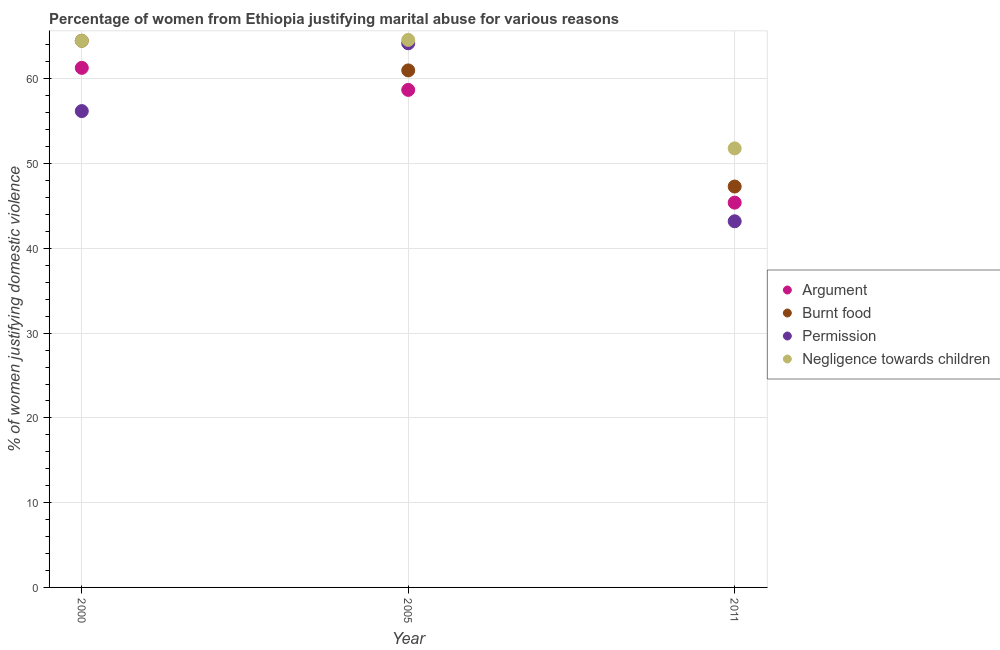How many different coloured dotlines are there?
Your answer should be compact. 4. Is the number of dotlines equal to the number of legend labels?
Ensure brevity in your answer.  Yes. What is the percentage of women justifying abuse for going without permission in 2011?
Make the answer very short. 43.2. Across all years, what is the maximum percentage of women justifying abuse in the case of an argument?
Ensure brevity in your answer.  61.3. Across all years, what is the minimum percentage of women justifying abuse for burning food?
Offer a terse response. 47.3. In which year was the percentage of women justifying abuse in the case of an argument maximum?
Give a very brief answer. 2000. In which year was the percentage of women justifying abuse for going without permission minimum?
Give a very brief answer. 2011. What is the total percentage of women justifying abuse for going without permission in the graph?
Offer a terse response. 163.6. What is the difference between the percentage of women justifying abuse for showing negligence towards children in 2000 and that in 2011?
Your answer should be very brief. 12.7. What is the difference between the percentage of women justifying abuse for showing negligence towards children in 2011 and the percentage of women justifying abuse for burning food in 2000?
Keep it short and to the point. -12.7. What is the average percentage of women justifying abuse in the case of an argument per year?
Make the answer very short. 55.13. In the year 2000, what is the difference between the percentage of women justifying abuse in the case of an argument and percentage of women justifying abuse for burning food?
Keep it short and to the point. -3.2. What is the ratio of the percentage of women justifying abuse for showing negligence towards children in 2000 to that in 2011?
Make the answer very short. 1.25. What is the difference between the highest and the second highest percentage of women justifying abuse in the case of an argument?
Your response must be concise. 2.6. What is the difference between the highest and the lowest percentage of women justifying abuse for burning food?
Make the answer very short. 17.2. In how many years, is the percentage of women justifying abuse in the case of an argument greater than the average percentage of women justifying abuse in the case of an argument taken over all years?
Make the answer very short. 2. Does the percentage of women justifying abuse for showing negligence towards children monotonically increase over the years?
Ensure brevity in your answer.  No. Is the percentage of women justifying abuse in the case of an argument strictly greater than the percentage of women justifying abuse for burning food over the years?
Your response must be concise. No. Is the percentage of women justifying abuse for showing negligence towards children strictly less than the percentage of women justifying abuse for burning food over the years?
Ensure brevity in your answer.  No. How many dotlines are there?
Keep it short and to the point. 4. How many years are there in the graph?
Keep it short and to the point. 3. Are the values on the major ticks of Y-axis written in scientific E-notation?
Provide a short and direct response. No. Does the graph contain grids?
Your answer should be very brief. Yes. How are the legend labels stacked?
Ensure brevity in your answer.  Vertical. What is the title of the graph?
Make the answer very short. Percentage of women from Ethiopia justifying marital abuse for various reasons. Does "Gender equality" appear as one of the legend labels in the graph?
Provide a succinct answer. No. What is the label or title of the X-axis?
Keep it short and to the point. Year. What is the label or title of the Y-axis?
Offer a very short reply. % of women justifying domestic violence. What is the % of women justifying domestic violence in Argument in 2000?
Your response must be concise. 61.3. What is the % of women justifying domestic violence of Burnt food in 2000?
Make the answer very short. 64.5. What is the % of women justifying domestic violence of Permission in 2000?
Your response must be concise. 56.2. What is the % of women justifying domestic violence of Negligence towards children in 2000?
Give a very brief answer. 64.5. What is the % of women justifying domestic violence in Argument in 2005?
Offer a terse response. 58.7. What is the % of women justifying domestic violence of Burnt food in 2005?
Provide a short and direct response. 61. What is the % of women justifying domestic violence in Permission in 2005?
Your answer should be compact. 64.2. What is the % of women justifying domestic violence in Negligence towards children in 2005?
Your answer should be compact. 64.6. What is the % of women justifying domestic violence of Argument in 2011?
Ensure brevity in your answer.  45.4. What is the % of women justifying domestic violence of Burnt food in 2011?
Offer a very short reply. 47.3. What is the % of women justifying domestic violence in Permission in 2011?
Offer a very short reply. 43.2. What is the % of women justifying domestic violence of Negligence towards children in 2011?
Ensure brevity in your answer.  51.8. Across all years, what is the maximum % of women justifying domestic violence in Argument?
Make the answer very short. 61.3. Across all years, what is the maximum % of women justifying domestic violence of Burnt food?
Offer a terse response. 64.5. Across all years, what is the maximum % of women justifying domestic violence of Permission?
Offer a very short reply. 64.2. Across all years, what is the maximum % of women justifying domestic violence in Negligence towards children?
Your response must be concise. 64.6. Across all years, what is the minimum % of women justifying domestic violence of Argument?
Give a very brief answer. 45.4. Across all years, what is the minimum % of women justifying domestic violence in Burnt food?
Provide a short and direct response. 47.3. Across all years, what is the minimum % of women justifying domestic violence in Permission?
Your answer should be compact. 43.2. Across all years, what is the minimum % of women justifying domestic violence of Negligence towards children?
Provide a short and direct response. 51.8. What is the total % of women justifying domestic violence of Argument in the graph?
Your response must be concise. 165.4. What is the total % of women justifying domestic violence of Burnt food in the graph?
Provide a short and direct response. 172.8. What is the total % of women justifying domestic violence of Permission in the graph?
Your response must be concise. 163.6. What is the total % of women justifying domestic violence in Negligence towards children in the graph?
Make the answer very short. 180.9. What is the difference between the % of women justifying domestic violence of Argument in 2000 and that in 2005?
Give a very brief answer. 2.6. What is the difference between the % of women justifying domestic violence of Argument in 2000 and that in 2011?
Ensure brevity in your answer.  15.9. What is the difference between the % of women justifying domestic violence of Burnt food in 2000 and that in 2011?
Give a very brief answer. 17.2. What is the difference between the % of women justifying domestic violence in Negligence towards children in 2000 and that in 2011?
Offer a terse response. 12.7. What is the difference between the % of women justifying domestic violence of Argument in 2005 and that in 2011?
Make the answer very short. 13.3. What is the difference between the % of women justifying domestic violence of Burnt food in 2005 and that in 2011?
Provide a short and direct response. 13.7. What is the difference between the % of women justifying domestic violence of Permission in 2005 and that in 2011?
Offer a very short reply. 21. What is the difference between the % of women justifying domestic violence in Argument in 2000 and the % of women justifying domestic violence in Negligence towards children in 2005?
Give a very brief answer. -3.3. What is the difference between the % of women justifying domestic violence of Burnt food in 2000 and the % of women justifying domestic violence of Permission in 2005?
Provide a short and direct response. 0.3. What is the difference between the % of women justifying domestic violence of Argument in 2000 and the % of women justifying domestic violence of Burnt food in 2011?
Your answer should be compact. 14. What is the difference between the % of women justifying domestic violence in Argument in 2000 and the % of women justifying domestic violence in Permission in 2011?
Provide a short and direct response. 18.1. What is the difference between the % of women justifying domestic violence in Burnt food in 2000 and the % of women justifying domestic violence in Permission in 2011?
Make the answer very short. 21.3. What is the difference between the % of women justifying domestic violence of Permission in 2000 and the % of women justifying domestic violence of Negligence towards children in 2011?
Your response must be concise. 4.4. What is the difference between the % of women justifying domestic violence of Argument in 2005 and the % of women justifying domestic violence of Permission in 2011?
Ensure brevity in your answer.  15.5. What is the difference between the % of women justifying domestic violence in Burnt food in 2005 and the % of women justifying domestic violence in Negligence towards children in 2011?
Provide a succinct answer. 9.2. What is the difference between the % of women justifying domestic violence in Permission in 2005 and the % of women justifying domestic violence in Negligence towards children in 2011?
Give a very brief answer. 12.4. What is the average % of women justifying domestic violence in Argument per year?
Keep it short and to the point. 55.13. What is the average % of women justifying domestic violence of Burnt food per year?
Your answer should be compact. 57.6. What is the average % of women justifying domestic violence of Permission per year?
Make the answer very short. 54.53. What is the average % of women justifying domestic violence of Negligence towards children per year?
Your answer should be very brief. 60.3. In the year 2000, what is the difference between the % of women justifying domestic violence in Permission and % of women justifying domestic violence in Negligence towards children?
Ensure brevity in your answer.  -8.3. In the year 2005, what is the difference between the % of women justifying domestic violence in Argument and % of women justifying domestic violence in Permission?
Your response must be concise. -5.5. In the year 2005, what is the difference between the % of women justifying domestic violence of Permission and % of women justifying domestic violence of Negligence towards children?
Provide a succinct answer. -0.4. In the year 2011, what is the difference between the % of women justifying domestic violence of Argument and % of women justifying domestic violence of Burnt food?
Provide a short and direct response. -1.9. In the year 2011, what is the difference between the % of women justifying domestic violence in Argument and % of women justifying domestic violence in Negligence towards children?
Make the answer very short. -6.4. In the year 2011, what is the difference between the % of women justifying domestic violence of Burnt food and % of women justifying domestic violence of Permission?
Make the answer very short. 4.1. In the year 2011, what is the difference between the % of women justifying domestic violence in Burnt food and % of women justifying domestic violence in Negligence towards children?
Offer a terse response. -4.5. In the year 2011, what is the difference between the % of women justifying domestic violence in Permission and % of women justifying domestic violence in Negligence towards children?
Your response must be concise. -8.6. What is the ratio of the % of women justifying domestic violence in Argument in 2000 to that in 2005?
Provide a succinct answer. 1.04. What is the ratio of the % of women justifying domestic violence in Burnt food in 2000 to that in 2005?
Provide a succinct answer. 1.06. What is the ratio of the % of women justifying domestic violence in Permission in 2000 to that in 2005?
Offer a terse response. 0.88. What is the ratio of the % of women justifying domestic violence in Negligence towards children in 2000 to that in 2005?
Your response must be concise. 1. What is the ratio of the % of women justifying domestic violence in Argument in 2000 to that in 2011?
Keep it short and to the point. 1.35. What is the ratio of the % of women justifying domestic violence in Burnt food in 2000 to that in 2011?
Keep it short and to the point. 1.36. What is the ratio of the % of women justifying domestic violence in Permission in 2000 to that in 2011?
Keep it short and to the point. 1.3. What is the ratio of the % of women justifying domestic violence in Negligence towards children in 2000 to that in 2011?
Your answer should be very brief. 1.25. What is the ratio of the % of women justifying domestic violence in Argument in 2005 to that in 2011?
Offer a very short reply. 1.29. What is the ratio of the % of women justifying domestic violence of Burnt food in 2005 to that in 2011?
Make the answer very short. 1.29. What is the ratio of the % of women justifying domestic violence of Permission in 2005 to that in 2011?
Your response must be concise. 1.49. What is the ratio of the % of women justifying domestic violence of Negligence towards children in 2005 to that in 2011?
Your answer should be very brief. 1.25. What is the difference between the highest and the second highest % of women justifying domestic violence in Burnt food?
Your answer should be very brief. 3.5. What is the difference between the highest and the second highest % of women justifying domestic violence in Permission?
Your response must be concise. 8. What is the difference between the highest and the lowest % of women justifying domestic violence of Permission?
Ensure brevity in your answer.  21. What is the difference between the highest and the lowest % of women justifying domestic violence of Negligence towards children?
Make the answer very short. 12.8. 